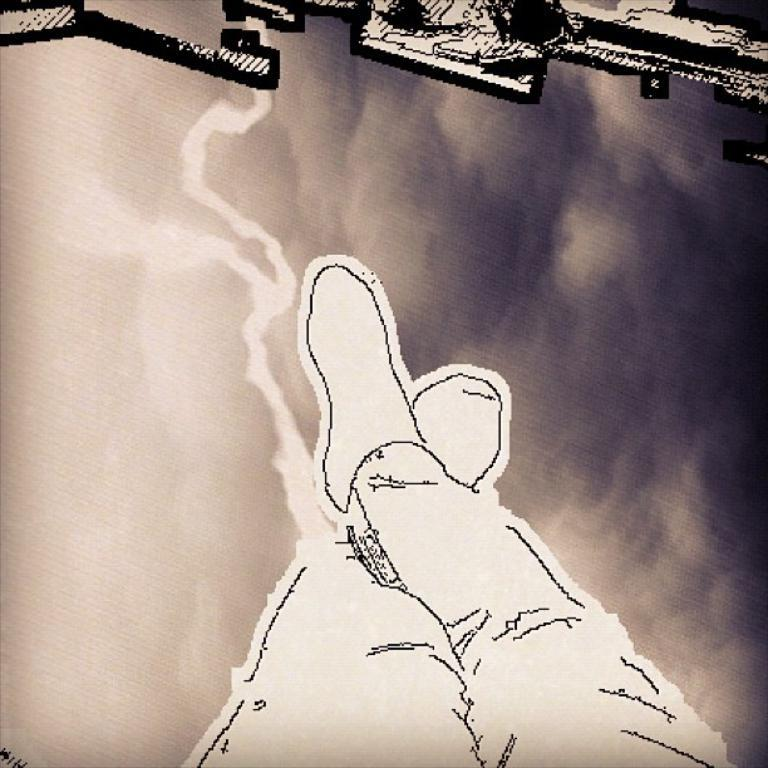What type of image is being described? The image is a collage. What can be seen in the collage? There are legs of a person visible in the image. What type of music can be heard playing in the background of the image? There is no music present in the image, as it is a still collage. 